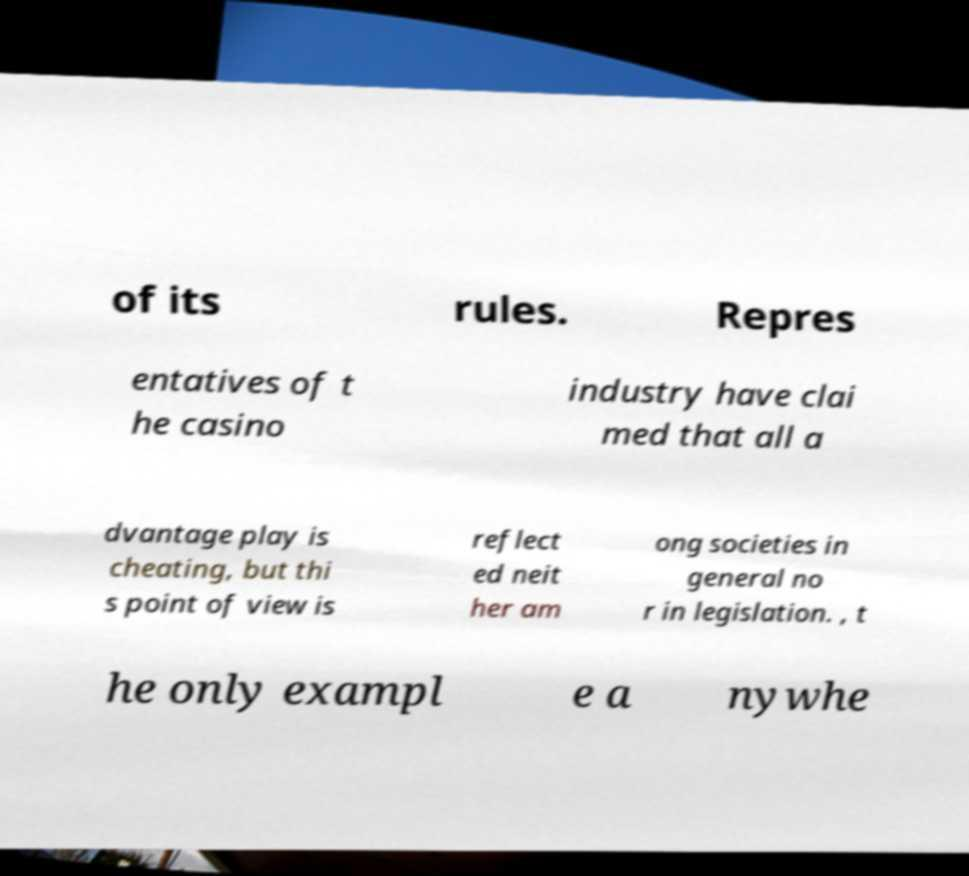Please identify and transcribe the text found in this image. of its rules. Repres entatives of t he casino industry have clai med that all a dvantage play is cheating, but thi s point of view is reflect ed neit her am ong societies in general no r in legislation. , t he only exampl e a nywhe 